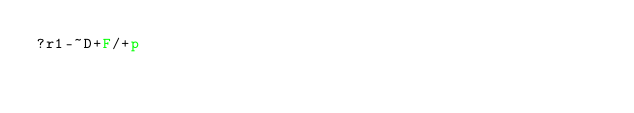<code> <loc_0><loc_0><loc_500><loc_500><_dc_>?r1-~D+F/+p</code> 